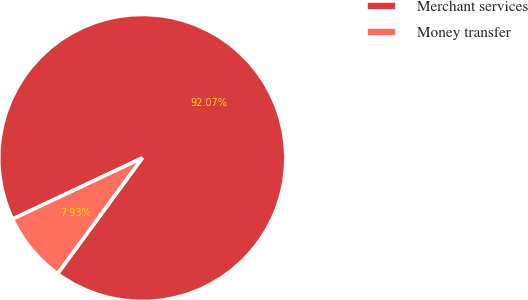Convert chart to OTSL. <chart><loc_0><loc_0><loc_500><loc_500><pie_chart><fcel>Merchant services<fcel>Money transfer<nl><fcel>92.07%<fcel>7.93%<nl></chart> 